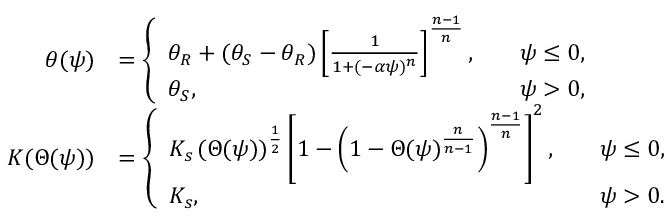<formula> <loc_0><loc_0><loc_500><loc_500>\begin{array} { r l } { \theta ( \psi ) } & { = \left \{ \begin{array} { l l } { \theta _ { R } + ( \theta _ { S } - \theta _ { R } ) \left [ \frac { 1 } { 1 + ( - \alpha \psi ) ^ { n } } \right ] ^ { \frac { n - 1 } { n } } , \quad } & { \psi \leq 0 , } \\ { \theta _ { S } , \quad } & { \psi > 0 , } \end{array} } \\ { K ( \Theta ( \psi ) ) } & { = \left \{ \begin{array} { l l } { K _ { s } \, ( \Theta ( \psi ) ) ^ { \frac { 1 } { 2 } } \left [ 1 - \left ( 1 - \Theta ( \psi ) ^ { \frac { n } { n - 1 } } \right ) ^ { \frac { n - 1 } { n } } \right ] ^ { 2 } , \quad } & { \psi \leq 0 , } \\ { K _ { s } , \quad } & { \psi > 0 . } \end{array} } \end{array}</formula> 